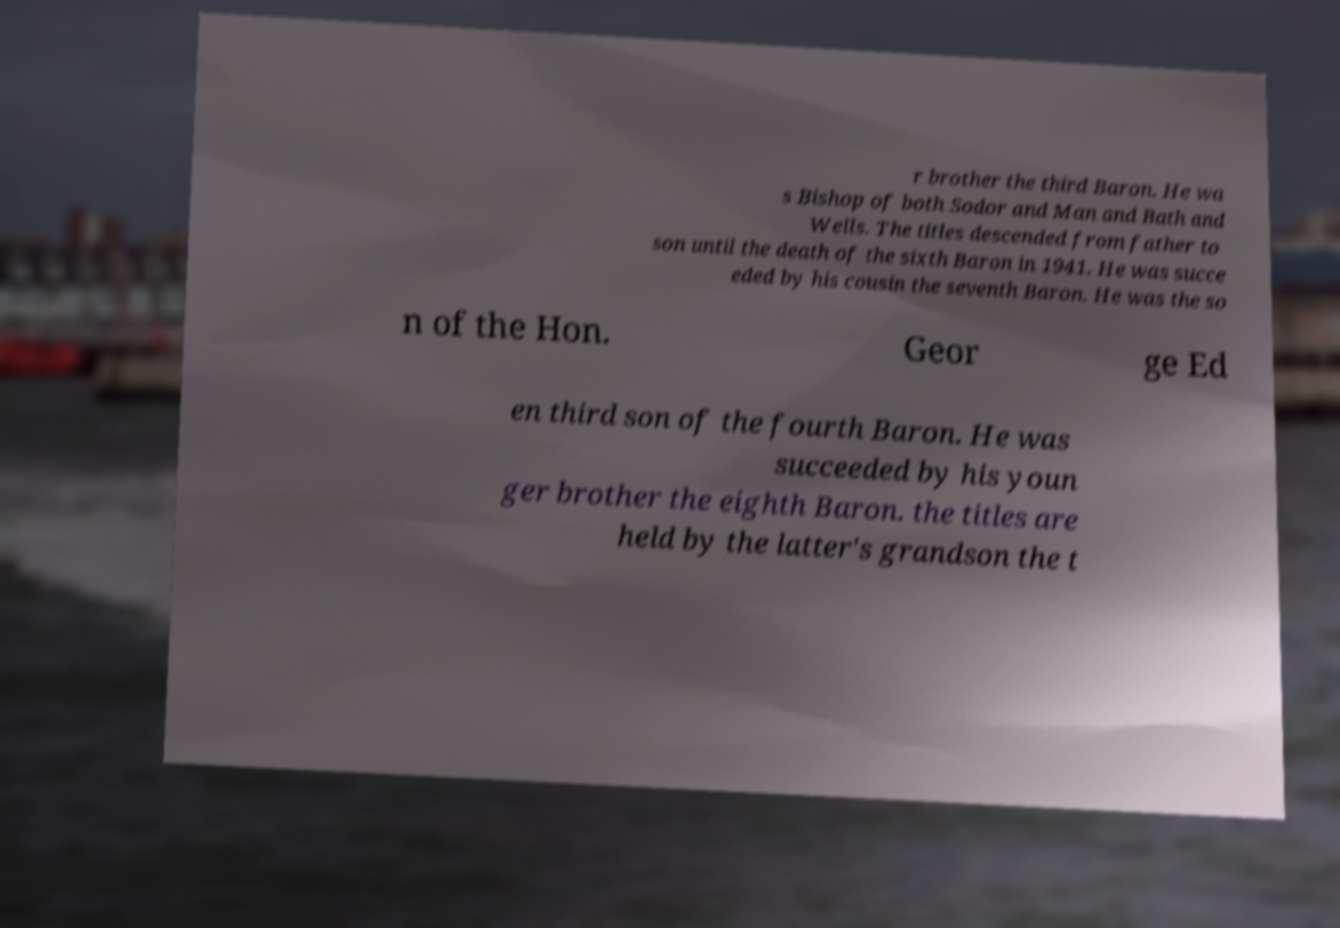For documentation purposes, I need the text within this image transcribed. Could you provide that? r brother the third Baron. He wa s Bishop of both Sodor and Man and Bath and Wells. The titles descended from father to son until the death of the sixth Baron in 1941. He was succe eded by his cousin the seventh Baron. He was the so n of the Hon. Geor ge Ed en third son of the fourth Baron. He was succeeded by his youn ger brother the eighth Baron. the titles are held by the latter's grandson the t 